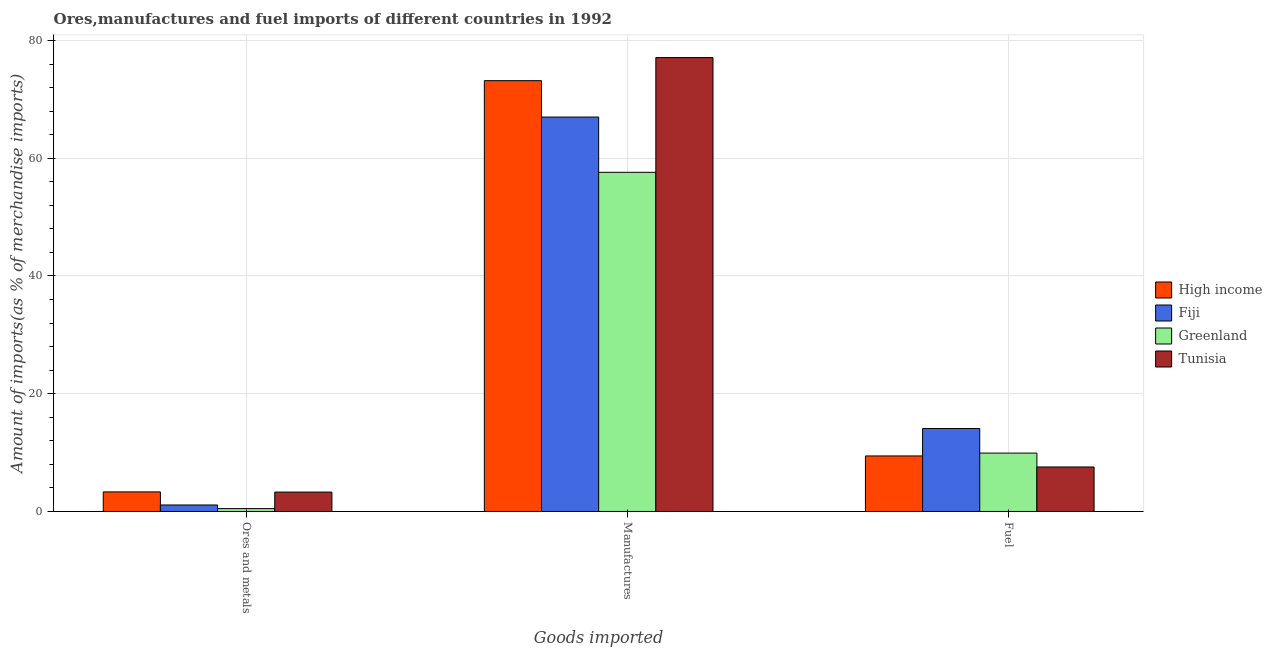Are the number of bars per tick equal to the number of legend labels?
Your answer should be very brief. Yes. How many bars are there on the 1st tick from the left?
Give a very brief answer. 4. What is the label of the 3rd group of bars from the left?
Offer a very short reply. Fuel. What is the percentage of manufactures imports in High income?
Offer a terse response. 73.18. Across all countries, what is the maximum percentage of fuel imports?
Offer a terse response. 14.09. Across all countries, what is the minimum percentage of fuel imports?
Your response must be concise. 7.56. In which country was the percentage of fuel imports maximum?
Give a very brief answer. Fiji. In which country was the percentage of ores and metals imports minimum?
Give a very brief answer. Greenland. What is the total percentage of manufactures imports in the graph?
Provide a succinct answer. 274.89. What is the difference between the percentage of fuel imports in Tunisia and that in Greenland?
Provide a succinct answer. -2.36. What is the difference between the percentage of manufactures imports in High income and the percentage of fuel imports in Fiji?
Provide a short and direct response. 59.08. What is the average percentage of manufactures imports per country?
Offer a very short reply. 68.72. What is the difference between the percentage of fuel imports and percentage of ores and metals imports in High income?
Offer a very short reply. 6.11. What is the ratio of the percentage of manufactures imports in Tunisia to that in High income?
Your answer should be very brief. 1.05. What is the difference between the highest and the second highest percentage of ores and metals imports?
Provide a short and direct response. 0.03. What is the difference between the highest and the lowest percentage of ores and metals imports?
Ensure brevity in your answer.  2.84. In how many countries, is the percentage of fuel imports greater than the average percentage of fuel imports taken over all countries?
Your answer should be compact. 1. What does the 2nd bar from the left in Ores and metals represents?
Provide a short and direct response. Fiji. What does the 3rd bar from the right in Ores and metals represents?
Provide a short and direct response. Fiji. Is it the case that in every country, the sum of the percentage of ores and metals imports and percentage of manufactures imports is greater than the percentage of fuel imports?
Offer a terse response. Yes. How many bars are there?
Offer a very short reply. 12. Are the values on the major ticks of Y-axis written in scientific E-notation?
Make the answer very short. No. Does the graph contain grids?
Your answer should be compact. Yes. What is the title of the graph?
Offer a terse response. Ores,manufactures and fuel imports of different countries in 1992. Does "Lower middle income" appear as one of the legend labels in the graph?
Provide a short and direct response. No. What is the label or title of the X-axis?
Offer a terse response. Goods imported. What is the label or title of the Y-axis?
Your answer should be very brief. Amount of imports(as % of merchandise imports). What is the Amount of imports(as % of merchandise imports) of High income in Ores and metals?
Make the answer very short. 3.33. What is the Amount of imports(as % of merchandise imports) in Fiji in Ores and metals?
Offer a very short reply. 1.1. What is the Amount of imports(as % of merchandise imports) of Greenland in Ores and metals?
Offer a terse response. 0.49. What is the Amount of imports(as % of merchandise imports) of Tunisia in Ores and metals?
Provide a succinct answer. 3.3. What is the Amount of imports(as % of merchandise imports) of High income in Manufactures?
Provide a short and direct response. 73.18. What is the Amount of imports(as % of merchandise imports) in Fiji in Manufactures?
Offer a terse response. 67. What is the Amount of imports(as % of merchandise imports) in Greenland in Manufactures?
Your answer should be very brief. 57.61. What is the Amount of imports(as % of merchandise imports) of Tunisia in Manufactures?
Your response must be concise. 77.1. What is the Amount of imports(as % of merchandise imports) in High income in Fuel?
Your answer should be very brief. 9.43. What is the Amount of imports(as % of merchandise imports) in Fiji in Fuel?
Give a very brief answer. 14.09. What is the Amount of imports(as % of merchandise imports) of Greenland in Fuel?
Your response must be concise. 9.92. What is the Amount of imports(as % of merchandise imports) of Tunisia in Fuel?
Keep it short and to the point. 7.56. Across all Goods imported, what is the maximum Amount of imports(as % of merchandise imports) in High income?
Give a very brief answer. 73.18. Across all Goods imported, what is the maximum Amount of imports(as % of merchandise imports) of Fiji?
Make the answer very short. 67. Across all Goods imported, what is the maximum Amount of imports(as % of merchandise imports) in Greenland?
Your answer should be compact. 57.61. Across all Goods imported, what is the maximum Amount of imports(as % of merchandise imports) of Tunisia?
Offer a very short reply. 77.1. Across all Goods imported, what is the minimum Amount of imports(as % of merchandise imports) in High income?
Offer a very short reply. 3.33. Across all Goods imported, what is the minimum Amount of imports(as % of merchandise imports) in Fiji?
Your answer should be very brief. 1.1. Across all Goods imported, what is the minimum Amount of imports(as % of merchandise imports) in Greenland?
Your answer should be very brief. 0.49. Across all Goods imported, what is the minimum Amount of imports(as % of merchandise imports) in Tunisia?
Keep it short and to the point. 3.3. What is the total Amount of imports(as % of merchandise imports) of High income in the graph?
Your answer should be very brief. 85.94. What is the total Amount of imports(as % of merchandise imports) in Fiji in the graph?
Provide a short and direct response. 82.2. What is the total Amount of imports(as % of merchandise imports) in Greenland in the graph?
Keep it short and to the point. 68.02. What is the total Amount of imports(as % of merchandise imports) of Tunisia in the graph?
Keep it short and to the point. 87.95. What is the difference between the Amount of imports(as % of merchandise imports) in High income in Ores and metals and that in Manufactures?
Make the answer very short. -69.85. What is the difference between the Amount of imports(as % of merchandise imports) of Fiji in Ores and metals and that in Manufactures?
Give a very brief answer. -65.9. What is the difference between the Amount of imports(as % of merchandise imports) of Greenland in Ores and metals and that in Manufactures?
Your answer should be compact. -57.12. What is the difference between the Amount of imports(as % of merchandise imports) in Tunisia in Ores and metals and that in Manufactures?
Offer a very short reply. -73.8. What is the difference between the Amount of imports(as % of merchandise imports) in High income in Ores and metals and that in Fuel?
Your response must be concise. -6.11. What is the difference between the Amount of imports(as % of merchandise imports) of Fiji in Ores and metals and that in Fuel?
Give a very brief answer. -12.99. What is the difference between the Amount of imports(as % of merchandise imports) of Greenland in Ores and metals and that in Fuel?
Offer a terse response. -9.43. What is the difference between the Amount of imports(as % of merchandise imports) of Tunisia in Ores and metals and that in Fuel?
Your answer should be compact. -4.26. What is the difference between the Amount of imports(as % of merchandise imports) in High income in Manufactures and that in Fuel?
Your response must be concise. 63.75. What is the difference between the Amount of imports(as % of merchandise imports) in Fiji in Manufactures and that in Fuel?
Your answer should be compact. 52.9. What is the difference between the Amount of imports(as % of merchandise imports) of Greenland in Manufactures and that in Fuel?
Keep it short and to the point. 47.69. What is the difference between the Amount of imports(as % of merchandise imports) in Tunisia in Manufactures and that in Fuel?
Your answer should be compact. 69.54. What is the difference between the Amount of imports(as % of merchandise imports) in High income in Ores and metals and the Amount of imports(as % of merchandise imports) in Fiji in Manufactures?
Offer a very short reply. -63.67. What is the difference between the Amount of imports(as % of merchandise imports) of High income in Ores and metals and the Amount of imports(as % of merchandise imports) of Greenland in Manufactures?
Ensure brevity in your answer.  -54.28. What is the difference between the Amount of imports(as % of merchandise imports) of High income in Ores and metals and the Amount of imports(as % of merchandise imports) of Tunisia in Manufactures?
Your response must be concise. -73.77. What is the difference between the Amount of imports(as % of merchandise imports) of Fiji in Ores and metals and the Amount of imports(as % of merchandise imports) of Greenland in Manufactures?
Offer a very short reply. -56.5. What is the difference between the Amount of imports(as % of merchandise imports) of Fiji in Ores and metals and the Amount of imports(as % of merchandise imports) of Tunisia in Manufactures?
Offer a very short reply. -76. What is the difference between the Amount of imports(as % of merchandise imports) of Greenland in Ores and metals and the Amount of imports(as % of merchandise imports) of Tunisia in Manufactures?
Offer a very short reply. -76.61. What is the difference between the Amount of imports(as % of merchandise imports) of High income in Ores and metals and the Amount of imports(as % of merchandise imports) of Fiji in Fuel?
Offer a very short reply. -10.77. What is the difference between the Amount of imports(as % of merchandise imports) in High income in Ores and metals and the Amount of imports(as % of merchandise imports) in Greenland in Fuel?
Give a very brief answer. -6.59. What is the difference between the Amount of imports(as % of merchandise imports) in High income in Ores and metals and the Amount of imports(as % of merchandise imports) in Tunisia in Fuel?
Provide a short and direct response. -4.23. What is the difference between the Amount of imports(as % of merchandise imports) of Fiji in Ores and metals and the Amount of imports(as % of merchandise imports) of Greenland in Fuel?
Offer a terse response. -8.82. What is the difference between the Amount of imports(as % of merchandise imports) of Fiji in Ores and metals and the Amount of imports(as % of merchandise imports) of Tunisia in Fuel?
Give a very brief answer. -6.46. What is the difference between the Amount of imports(as % of merchandise imports) in Greenland in Ores and metals and the Amount of imports(as % of merchandise imports) in Tunisia in Fuel?
Give a very brief answer. -7.07. What is the difference between the Amount of imports(as % of merchandise imports) in High income in Manufactures and the Amount of imports(as % of merchandise imports) in Fiji in Fuel?
Your answer should be compact. 59.08. What is the difference between the Amount of imports(as % of merchandise imports) in High income in Manufactures and the Amount of imports(as % of merchandise imports) in Greenland in Fuel?
Provide a short and direct response. 63.26. What is the difference between the Amount of imports(as % of merchandise imports) in High income in Manufactures and the Amount of imports(as % of merchandise imports) in Tunisia in Fuel?
Keep it short and to the point. 65.62. What is the difference between the Amount of imports(as % of merchandise imports) of Fiji in Manufactures and the Amount of imports(as % of merchandise imports) of Greenland in Fuel?
Provide a succinct answer. 57.08. What is the difference between the Amount of imports(as % of merchandise imports) in Fiji in Manufactures and the Amount of imports(as % of merchandise imports) in Tunisia in Fuel?
Offer a very short reply. 59.44. What is the difference between the Amount of imports(as % of merchandise imports) of Greenland in Manufactures and the Amount of imports(as % of merchandise imports) of Tunisia in Fuel?
Keep it short and to the point. 50.05. What is the average Amount of imports(as % of merchandise imports) in High income per Goods imported?
Offer a terse response. 28.65. What is the average Amount of imports(as % of merchandise imports) in Fiji per Goods imported?
Give a very brief answer. 27.4. What is the average Amount of imports(as % of merchandise imports) in Greenland per Goods imported?
Ensure brevity in your answer.  22.67. What is the average Amount of imports(as % of merchandise imports) in Tunisia per Goods imported?
Offer a terse response. 29.32. What is the difference between the Amount of imports(as % of merchandise imports) in High income and Amount of imports(as % of merchandise imports) in Fiji in Ores and metals?
Keep it short and to the point. 2.22. What is the difference between the Amount of imports(as % of merchandise imports) of High income and Amount of imports(as % of merchandise imports) of Greenland in Ores and metals?
Offer a very short reply. 2.84. What is the difference between the Amount of imports(as % of merchandise imports) of High income and Amount of imports(as % of merchandise imports) of Tunisia in Ores and metals?
Ensure brevity in your answer.  0.03. What is the difference between the Amount of imports(as % of merchandise imports) of Fiji and Amount of imports(as % of merchandise imports) of Greenland in Ores and metals?
Make the answer very short. 0.61. What is the difference between the Amount of imports(as % of merchandise imports) in Fiji and Amount of imports(as % of merchandise imports) in Tunisia in Ores and metals?
Your answer should be compact. -2.19. What is the difference between the Amount of imports(as % of merchandise imports) of Greenland and Amount of imports(as % of merchandise imports) of Tunisia in Ores and metals?
Make the answer very short. -2.8. What is the difference between the Amount of imports(as % of merchandise imports) of High income and Amount of imports(as % of merchandise imports) of Fiji in Manufactures?
Provide a short and direct response. 6.18. What is the difference between the Amount of imports(as % of merchandise imports) in High income and Amount of imports(as % of merchandise imports) in Greenland in Manufactures?
Your response must be concise. 15.57. What is the difference between the Amount of imports(as % of merchandise imports) of High income and Amount of imports(as % of merchandise imports) of Tunisia in Manufactures?
Give a very brief answer. -3.92. What is the difference between the Amount of imports(as % of merchandise imports) of Fiji and Amount of imports(as % of merchandise imports) of Greenland in Manufactures?
Offer a terse response. 9.39. What is the difference between the Amount of imports(as % of merchandise imports) of Fiji and Amount of imports(as % of merchandise imports) of Tunisia in Manufactures?
Make the answer very short. -10.1. What is the difference between the Amount of imports(as % of merchandise imports) in Greenland and Amount of imports(as % of merchandise imports) in Tunisia in Manufactures?
Make the answer very short. -19.49. What is the difference between the Amount of imports(as % of merchandise imports) of High income and Amount of imports(as % of merchandise imports) of Fiji in Fuel?
Make the answer very short. -4.66. What is the difference between the Amount of imports(as % of merchandise imports) in High income and Amount of imports(as % of merchandise imports) in Greenland in Fuel?
Your answer should be very brief. -0.49. What is the difference between the Amount of imports(as % of merchandise imports) of High income and Amount of imports(as % of merchandise imports) of Tunisia in Fuel?
Your answer should be very brief. 1.87. What is the difference between the Amount of imports(as % of merchandise imports) of Fiji and Amount of imports(as % of merchandise imports) of Greenland in Fuel?
Your answer should be compact. 4.18. What is the difference between the Amount of imports(as % of merchandise imports) of Fiji and Amount of imports(as % of merchandise imports) of Tunisia in Fuel?
Your response must be concise. 6.54. What is the difference between the Amount of imports(as % of merchandise imports) of Greenland and Amount of imports(as % of merchandise imports) of Tunisia in Fuel?
Your answer should be compact. 2.36. What is the ratio of the Amount of imports(as % of merchandise imports) in High income in Ores and metals to that in Manufactures?
Provide a succinct answer. 0.05. What is the ratio of the Amount of imports(as % of merchandise imports) in Fiji in Ores and metals to that in Manufactures?
Offer a terse response. 0.02. What is the ratio of the Amount of imports(as % of merchandise imports) of Greenland in Ores and metals to that in Manufactures?
Provide a short and direct response. 0.01. What is the ratio of the Amount of imports(as % of merchandise imports) of Tunisia in Ores and metals to that in Manufactures?
Ensure brevity in your answer.  0.04. What is the ratio of the Amount of imports(as % of merchandise imports) in High income in Ores and metals to that in Fuel?
Make the answer very short. 0.35. What is the ratio of the Amount of imports(as % of merchandise imports) of Fiji in Ores and metals to that in Fuel?
Provide a short and direct response. 0.08. What is the ratio of the Amount of imports(as % of merchandise imports) in Greenland in Ores and metals to that in Fuel?
Keep it short and to the point. 0.05. What is the ratio of the Amount of imports(as % of merchandise imports) in Tunisia in Ores and metals to that in Fuel?
Offer a terse response. 0.44. What is the ratio of the Amount of imports(as % of merchandise imports) of High income in Manufactures to that in Fuel?
Offer a terse response. 7.76. What is the ratio of the Amount of imports(as % of merchandise imports) in Fiji in Manufactures to that in Fuel?
Offer a very short reply. 4.75. What is the ratio of the Amount of imports(as % of merchandise imports) of Greenland in Manufactures to that in Fuel?
Your answer should be very brief. 5.81. What is the ratio of the Amount of imports(as % of merchandise imports) in Tunisia in Manufactures to that in Fuel?
Your answer should be very brief. 10.2. What is the difference between the highest and the second highest Amount of imports(as % of merchandise imports) in High income?
Your answer should be very brief. 63.75. What is the difference between the highest and the second highest Amount of imports(as % of merchandise imports) in Fiji?
Make the answer very short. 52.9. What is the difference between the highest and the second highest Amount of imports(as % of merchandise imports) of Greenland?
Keep it short and to the point. 47.69. What is the difference between the highest and the second highest Amount of imports(as % of merchandise imports) of Tunisia?
Provide a short and direct response. 69.54. What is the difference between the highest and the lowest Amount of imports(as % of merchandise imports) in High income?
Offer a very short reply. 69.85. What is the difference between the highest and the lowest Amount of imports(as % of merchandise imports) of Fiji?
Ensure brevity in your answer.  65.9. What is the difference between the highest and the lowest Amount of imports(as % of merchandise imports) in Greenland?
Ensure brevity in your answer.  57.12. What is the difference between the highest and the lowest Amount of imports(as % of merchandise imports) in Tunisia?
Your answer should be compact. 73.8. 